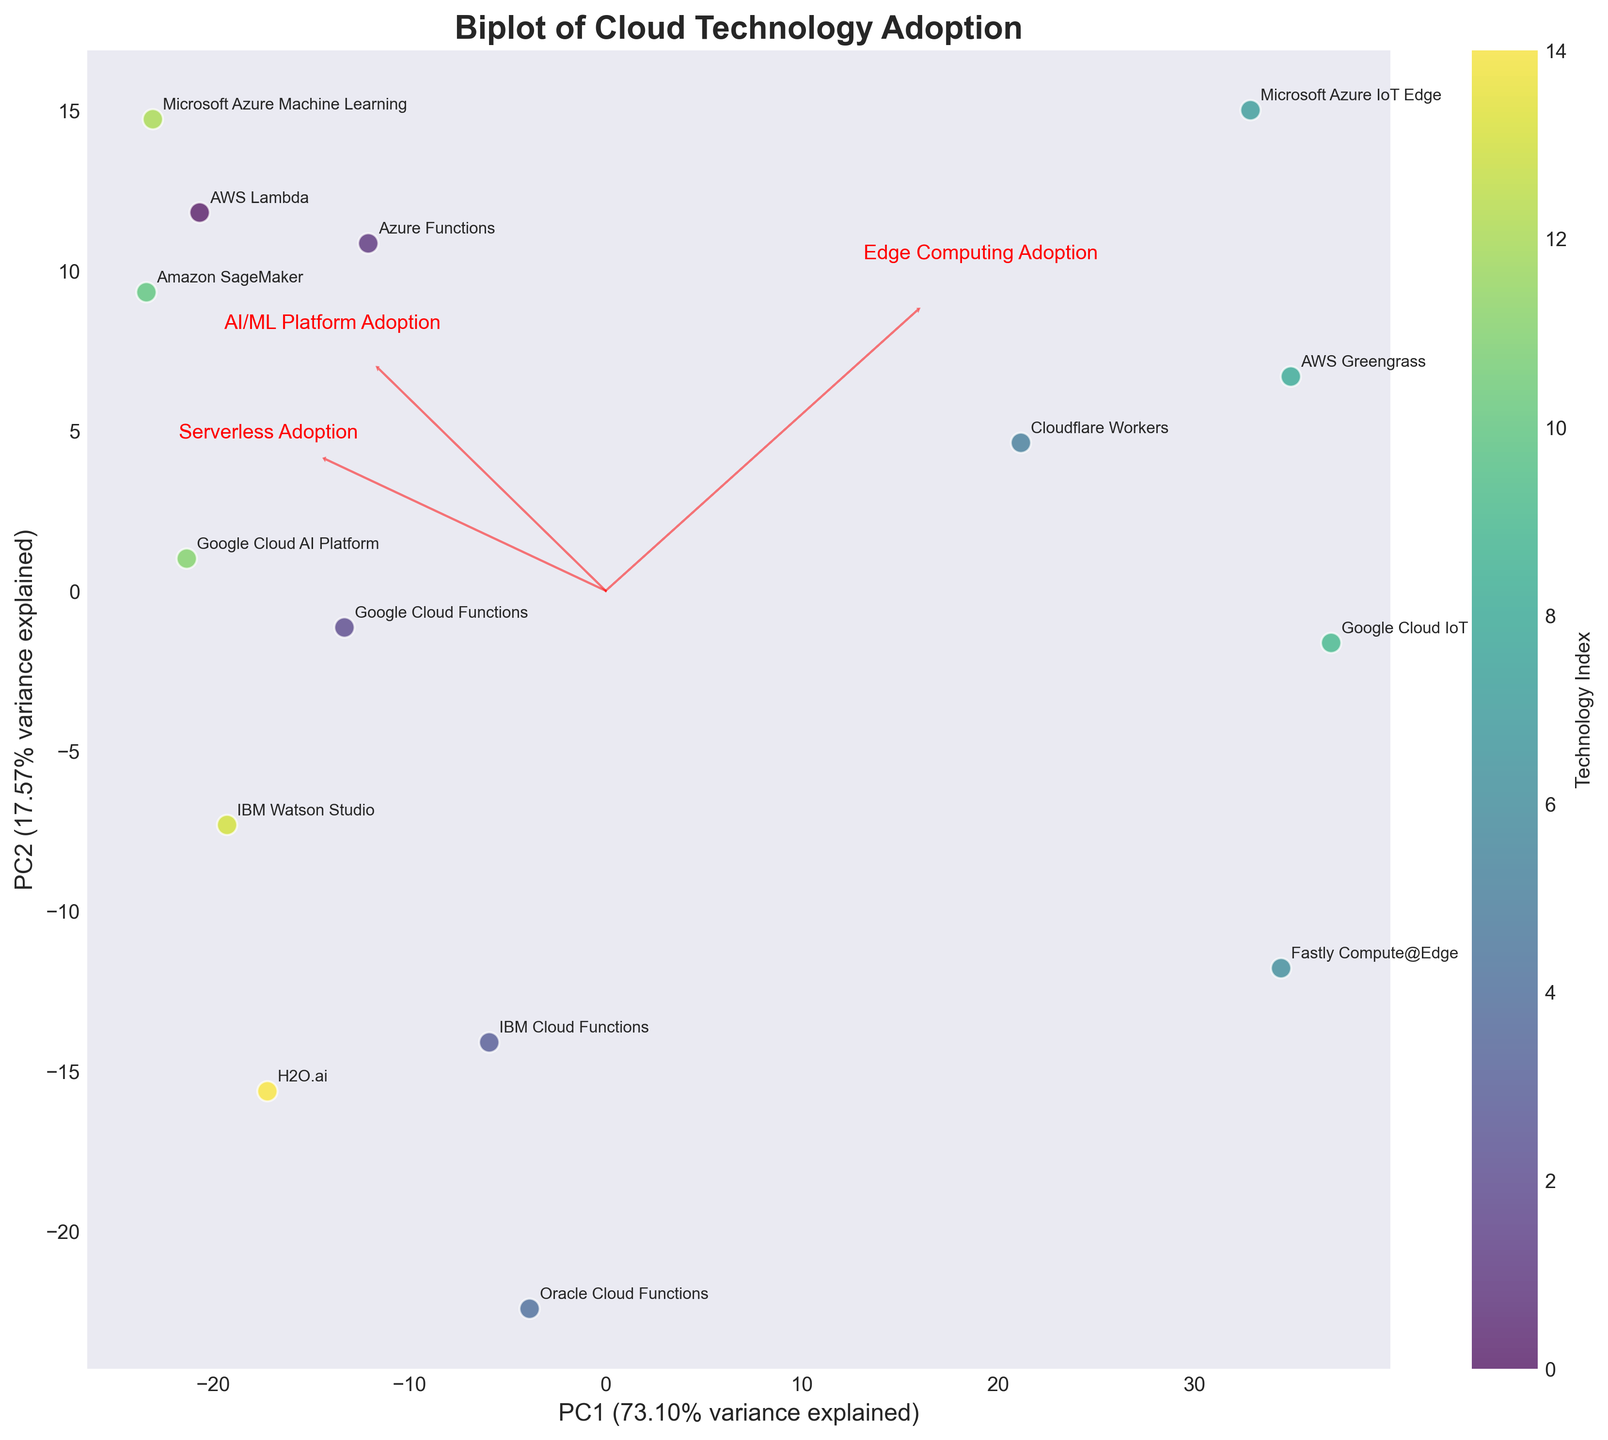What is the title of the biplot? The title of the plot is displayed at the top of the figure and summarizes its contents.
Answer: Biplot of Cloud Technology Adoption Which two technologies are located the farthest apart on the plot? By looking at the plot and assessing the distance between points representing technologies, the two technologies farthest apart are Microsoft Azure IoT Edge and IBM Watson Studio.
Answer: Microsoft Azure IoT Edge and IBM Watson Studio How many cloud technologies are plotted in the figure? Count the number of distinct labels or points in the plot. Each label represents a different cloud technology. There are 15 labels.
Answer: 15 Which two technologies have similar adoption rates in both serverless computing and AI/ML platforms? On the plot, look for points that are close to each other along both PC1 and PC2 axes. Amazon SageMaker and Microsoft Azure Machine Learning are close to each other.
Answer: Amazon SageMaker and Microsoft Azure Machine Learning Which technology has the highest adoption rate in edge computing? Identify the technology that lies furthest in the direction of the edge computing arrow (loading). Microsoft Azure IoT Edge is positioned closest to the edge computing arrow.
Answer: Microsoft Azure IoT Edge What percentage of the total variance is explained by the first principal component (PC1)? Read the label on the x-axis. The percentage of variance explained by PC1 is displayed next to the x-axis label.
Answer: 49.97% Compare the adoption rates of AWS Lambda and IBM Cloud Functions in serverless computing. Which one is higher? AWS Lambda and IBM Cloud Functions are represented by points. AWS Lambda is positioned more significantly along the direction of the serverless computing arrow (loading), indicating a higher adoption rate.
Answer: AWS Lambda Which cloud technology has balanced adoption rates across serverless computing, edge computing, and AI/ML platforms? Look for a point in the plot that is central and approximately equidistant from the loadings of all three features. Cloudflare Workers is relatively balanced across all three adoption rates.
Answer: Cloudflare Workers In which direction does the AI/ML Platform Adoption arrow point, and how does it relate to the positions of Amazon SageMaker and Microsoft Azure Machine Learning? The AI/ML Platform Adoption arrow points in the general direction where both Amazon SageMaker and Microsoft Azure Machine Learning are located, indicating high adoption rates in this area.
Answer: Towards Amazon SageMaker and Microsoft Azure Machine Learning Are the adoption rates of H2O.ai higher in serverless computing or AI/ML platforms? Find the position of H2O.ai on the plot and compare its distance along the directions of serverless computing and AI/ML platforms arrows. It is located closer in the direction of AI/ML platform adoption.
Answer: AI/ML platforms 